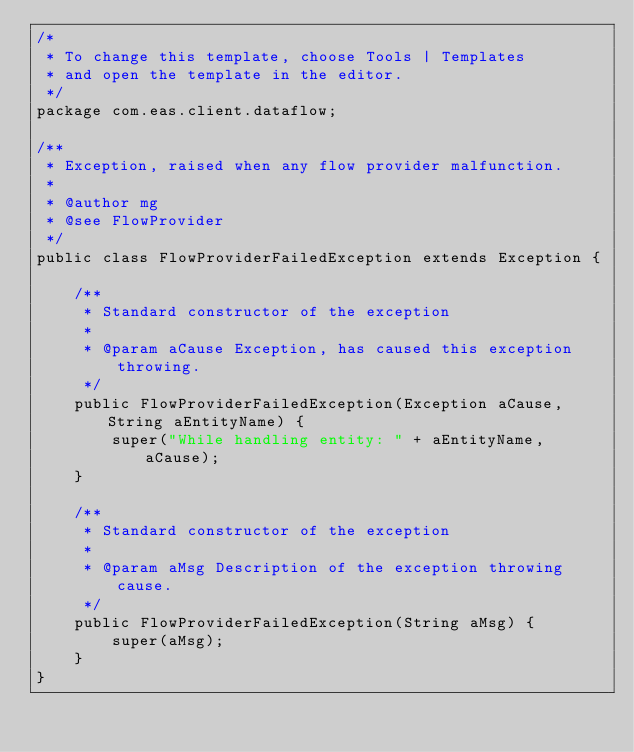Convert code to text. <code><loc_0><loc_0><loc_500><loc_500><_Java_>/*
 * To change this template, choose Tools | Templates
 * and open the template in the editor.
 */
package com.eas.client.dataflow;

/**
 * Exception, raised when any flow provider malfunction.
 *
 * @author mg
 * @see FlowProvider
 */
public class FlowProviderFailedException extends Exception {

    /**
     * Standard constructor of the exception
     *
     * @param aCause Exception, has caused this exception throwing.
     */
    public FlowProviderFailedException(Exception aCause, String aEntityName) {
        super("While handling entity: " + aEntityName, aCause);
    }

    /**
     * Standard constructor of the exception
     *
     * @param aMsg Description of the exception throwing cause.
     */
    public FlowProviderFailedException(String aMsg) {
        super(aMsg);
    }
}
</code> 